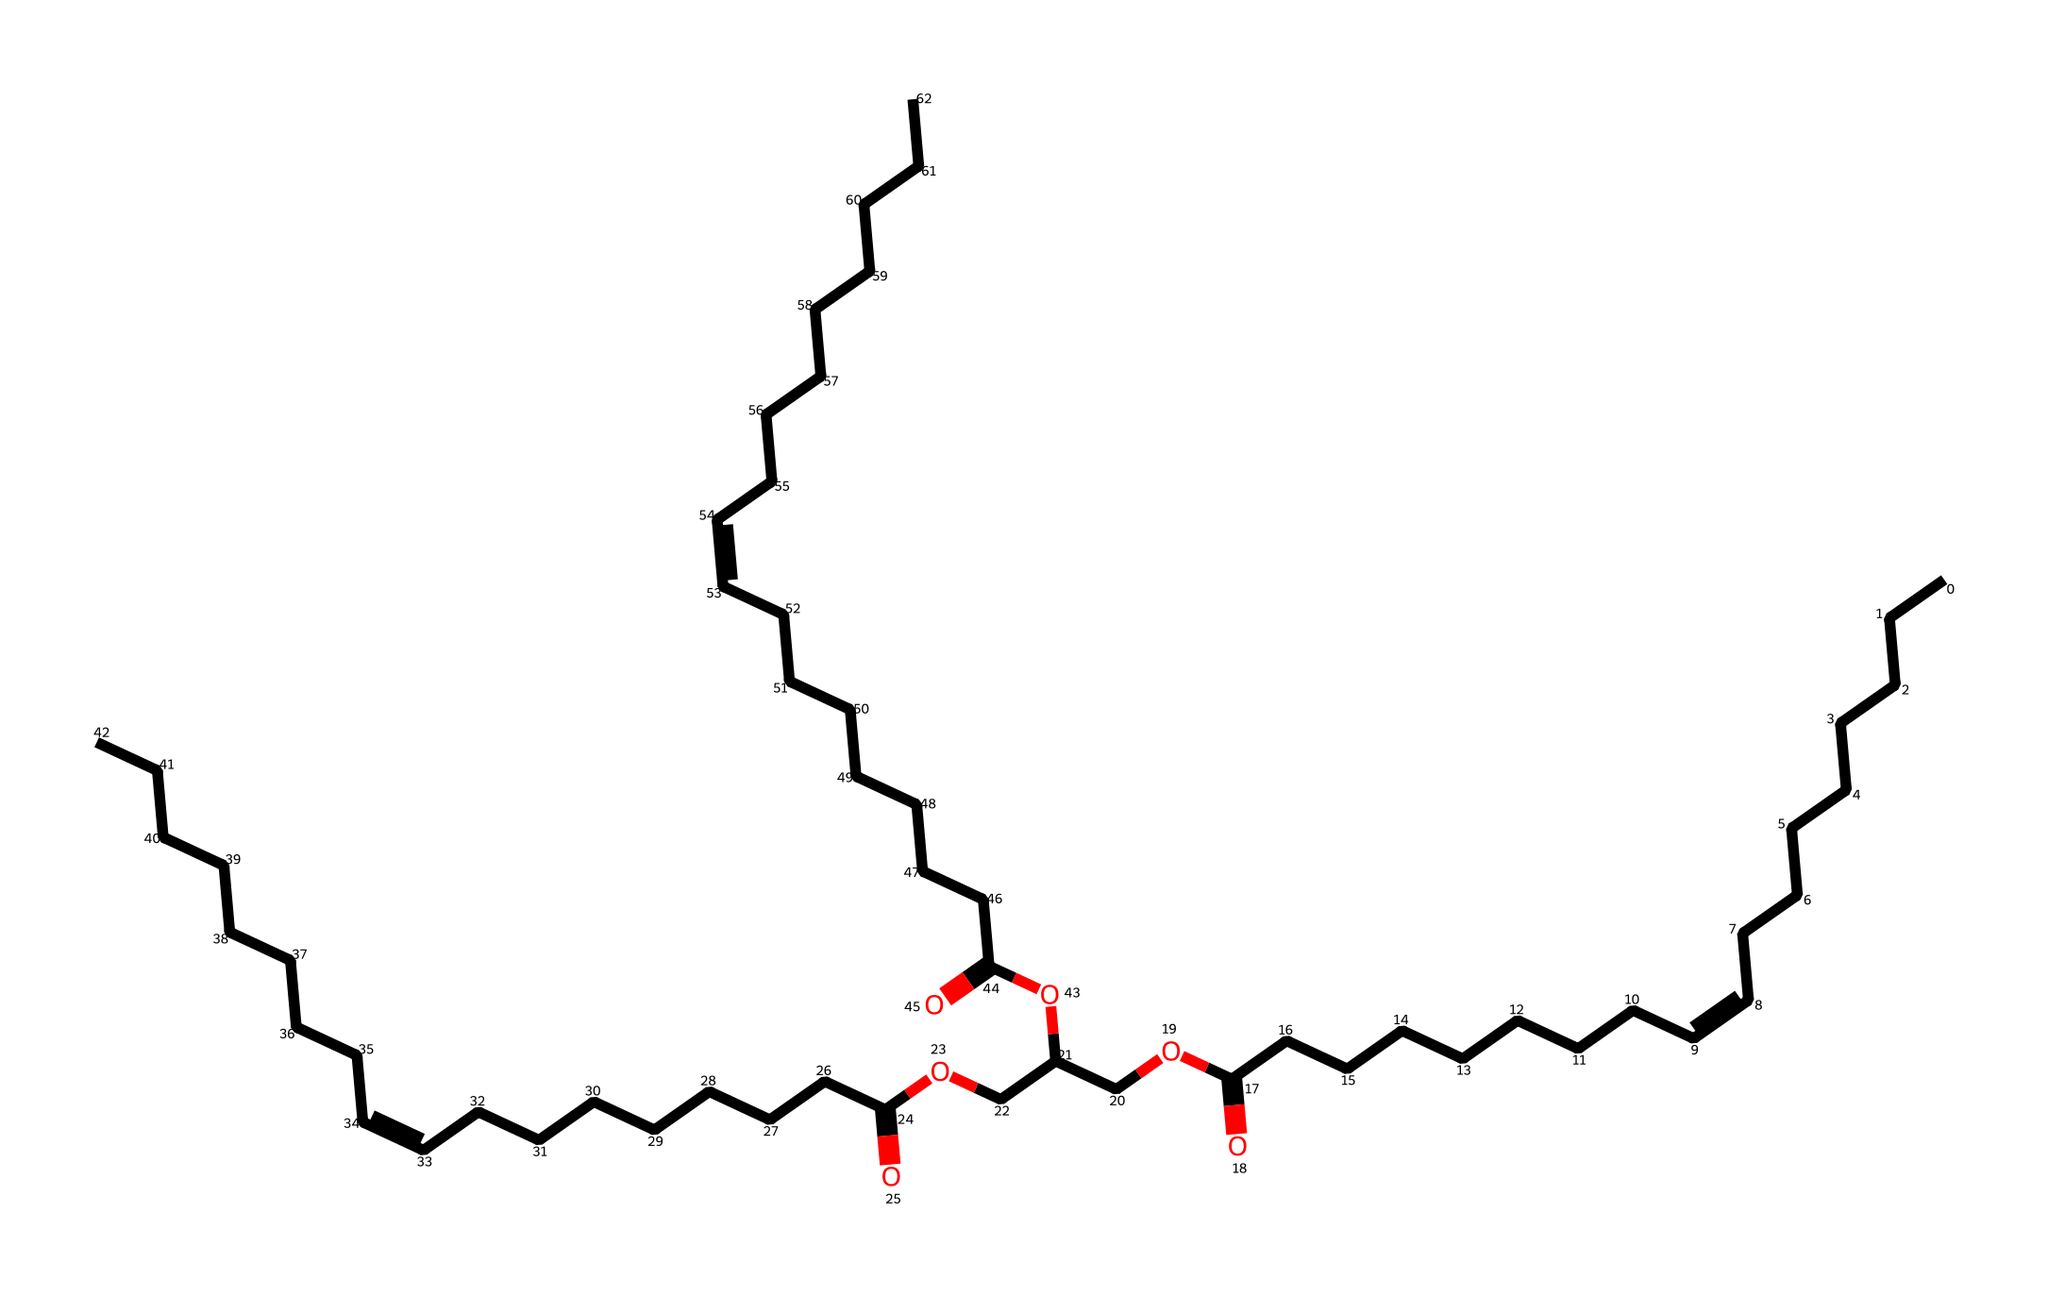What is the primary functional group present in soybean oil? The chemical structure includes a carboxylic acid group (-COOH) indicated by the carbon atom double-bonded to oxygen and single-bonded to an oxygen atom that connects to another carbon chain. This characteristic identifies the functional group as a carboxylic acid.
Answer: carboxylic acid How many carbon atoms are in the longest carbon chain of soybean oil? By examining the chemical structure, we can count the carbon atoms in the longest segmented chain, which totals 18 carbons, as observed in the straight-chain portions of the SMILES representation.
Answer: 18 What type of bonds are primarily present in the fatty acid chains of soybean oil? The visual representation shows that there are both single (saturated) and double (unsaturated) bonds in the fatty acid chains. The presence of the /C=C\ suggests that there are double bonds in the structure.
Answer: single and double bonds What property makes soybean oil a suitable biodegradable lubricant? The presence of long-chain fatty acids and the structure's natural constituents give soybean oil the property of biodegradability, which is essential for environmentally friendly lubricants.
Answer: biodegradability How many double bonds are present in the chemical structure of soybean oil? By analyzing the SMILES, we can identify the regions between the carbons that have double bonds indicated by /C=C\. Counting these areas reveals that there are three double bonds in the structure, essential for its unsaturation.
Answer: 3 What is the overall classification of soybean oil in terms of its physical state at room temperature? Given that soybean oil is a common cooking oil primarily composed of fatty acids, it is typically classified as a liquid at room temperature due to its unsaturated nature, which prevents it from solidifying.
Answer: liquid 